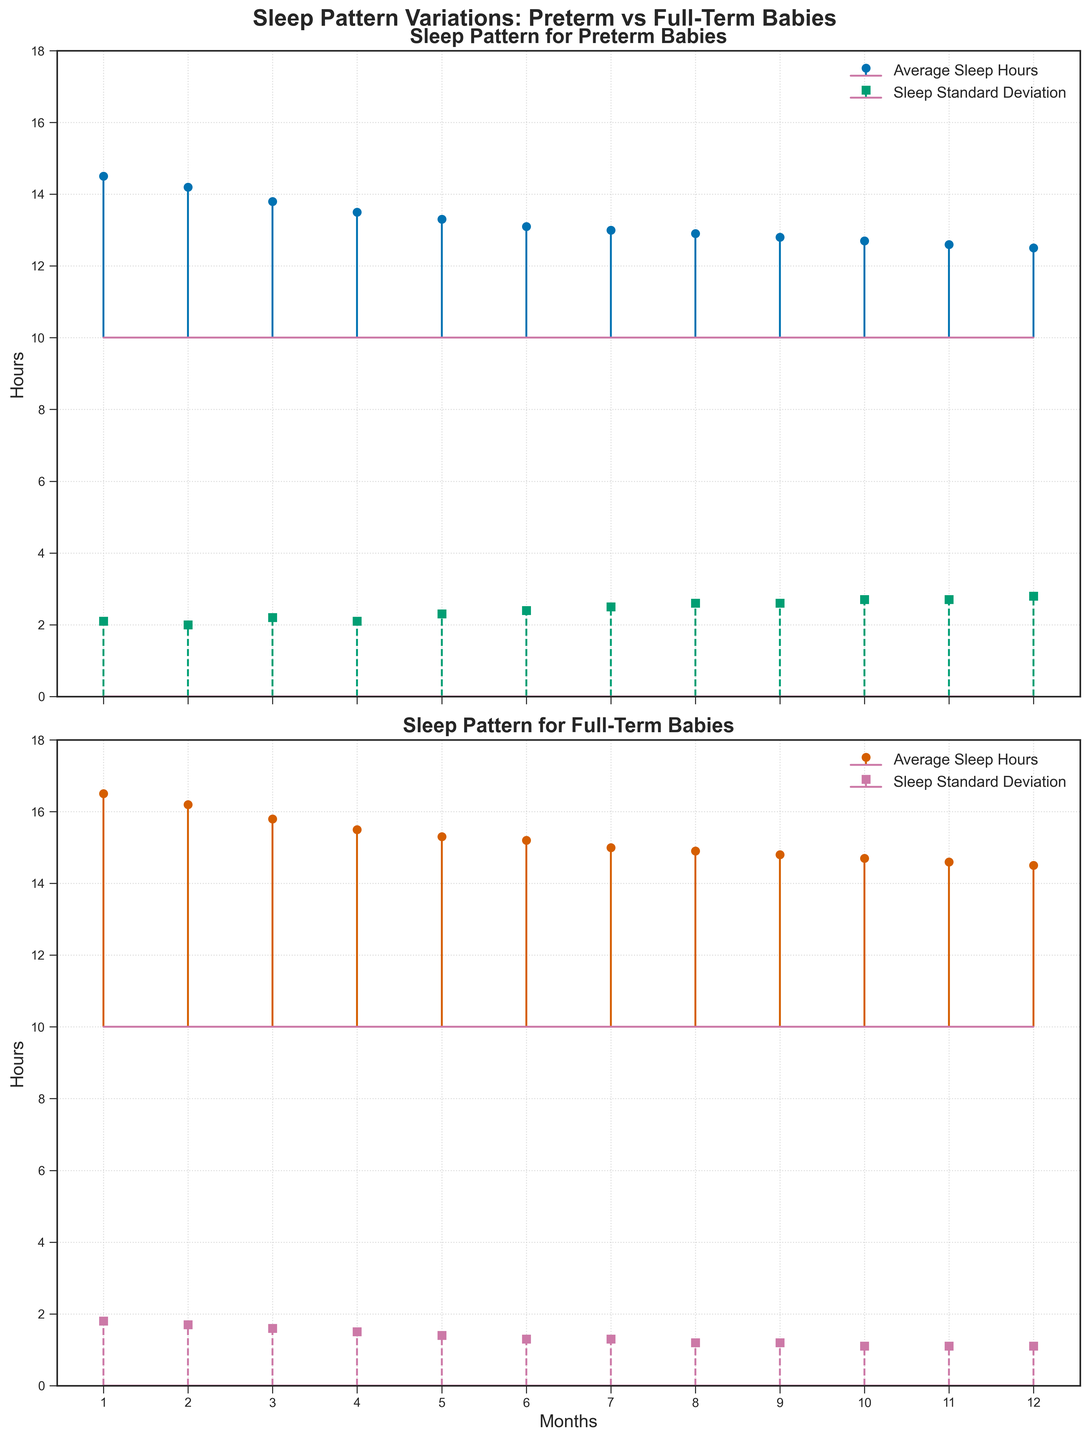What are the main titles of the two subplots? The titles of subplots are usually placed at the top of each subplot. For the first subplot, it is "Sleep Pattern for Preterm Babies" and for the second subplot, it is "Sleep Pattern for Full-Term Babies".
Answer: "Sleep Pattern for Preterm Babies" and "Sleep Pattern for Full-Term Babies" Which month shows the highest average sleep hours for preterm babies? By looking at the y-values of the stem plot lines for preterm average sleep hours, the highest value is 14.5 hours which occurs at month 1.
Answer: Month 1 How do the average sleep hours of full-term babies change over the first year? The average sleep hours for full-term babies decrease over time. They start at 16.5 hours in month 1 and gradually decrease to 14.5 hours by month 12, as indicated by the downward trend in the subplot.
Answer: Decrease At which months do the standard deviation of sleep hours for preterm and full-term babies become equal? The standard deviations for both preterm and full-term babies are represented by different colored markers, and intersecting points can be visually compared. In month 12, both standard deviations are 2.8 hours for preterm and 1.1 hours for full-term babies.
Answer: Month 12 Compare the variability in sleep hours between preterm and full-term babies over the first year. The standard deviation (shown by dashed stems) for preterm babies starts at 2.1 and increases up to 2.8, indicating more variability. The standard deviation for full-term babies starts at 1.8 and decreases to 1.1, indicating less variability.
Answer: Preterm babies have more variability By how many hours do the average sleep hours of preterm babies differ from full-term babies in month 6? The average sleep hours for preterm babies in month 6 is 13.1 hours and for full-term babies is 15.2 hours. The difference is calculated as 15.2 - 13.1.
Answer: 2.1 hours Which group shows a more consistent sleep pattern over the first year? Consistency in sleep patterns can be deduced from the standard deviation values. Full-term babies show standard deviation values decreasing from 1.8 to 1.1 over the year, hence exhibiting more consistency.
Answer: Full-term babies By looking at the plot, which month shows the smallest difference in average sleep hours between preterm and full-term babies? To find the smallest difference, compare the average sleep hours for each month and identify where the difference is minimum. In month 9, the difference is smallest (14.8 - 12.8) = 2 hours.
Answer: Month 9 